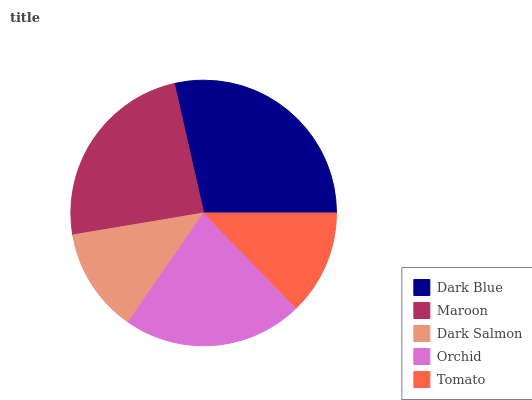Is Dark Salmon the minimum?
Answer yes or no. Yes. Is Dark Blue the maximum?
Answer yes or no. Yes. Is Maroon the minimum?
Answer yes or no. No. Is Maroon the maximum?
Answer yes or no. No. Is Dark Blue greater than Maroon?
Answer yes or no. Yes. Is Maroon less than Dark Blue?
Answer yes or no. Yes. Is Maroon greater than Dark Blue?
Answer yes or no. No. Is Dark Blue less than Maroon?
Answer yes or no. No. Is Orchid the high median?
Answer yes or no. Yes. Is Orchid the low median?
Answer yes or no. Yes. Is Dark Salmon the high median?
Answer yes or no. No. Is Maroon the low median?
Answer yes or no. No. 